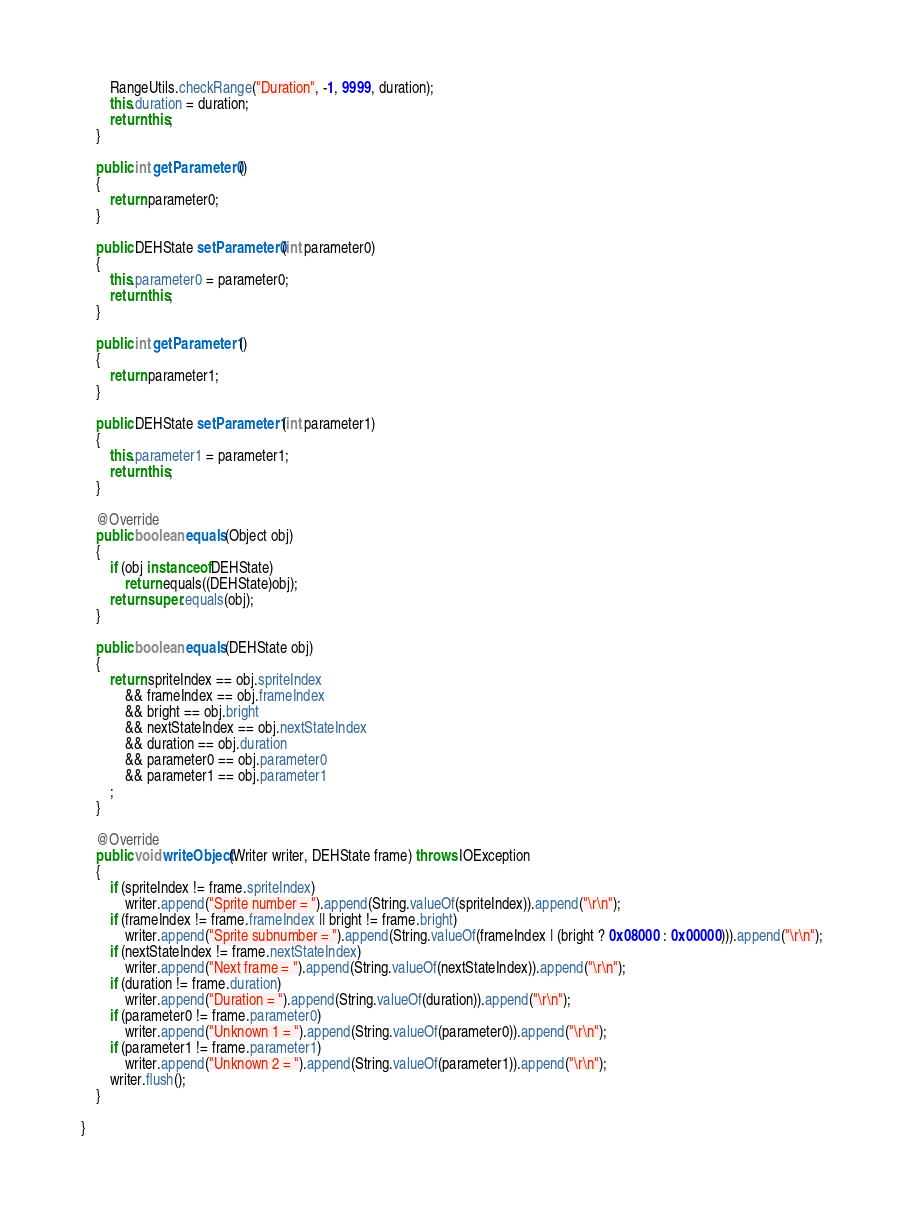Convert code to text. <code><loc_0><loc_0><loc_500><loc_500><_Java_>		RangeUtils.checkRange("Duration", -1, 9999, duration);
		this.duration = duration;
		return this;
	}
	
	public int getParameter0() 
	{
		return parameter0;
	}
	
	public DEHState setParameter0(int parameter0) 
	{
		this.parameter0 = parameter0;
		return this;
	}
	
	public int getParameter1()
	{
		return parameter1;
	}
	
	public DEHState setParameter1(int parameter1)
	{
		this.parameter1 = parameter1;
		return this;
	}
	
	@Override
	public boolean equals(Object obj) 
	{
		if (obj instanceof DEHState)
			return equals((DEHState)obj);
		return super.equals(obj);
	}
	
	public boolean equals(DEHState obj) 
	{
		return spriteIndex == obj.spriteIndex
			&& frameIndex == obj.frameIndex
			&& bright == obj.bright
			&& nextStateIndex == obj.nextStateIndex
			&& duration == obj.duration
			&& parameter0 == obj.parameter0
			&& parameter1 == obj.parameter1
		;
	}	
		
	@Override
	public void writeObject(Writer writer, DEHState frame) throws IOException
	{
		if (spriteIndex != frame.spriteIndex)
			writer.append("Sprite number = ").append(String.valueOf(spriteIndex)).append("\r\n");
		if (frameIndex != frame.frameIndex || bright != frame.bright)
			writer.append("Sprite subnumber = ").append(String.valueOf(frameIndex | (bright ? 0x08000 : 0x00000))).append("\r\n");
		if (nextStateIndex != frame.nextStateIndex)
			writer.append("Next frame = ").append(String.valueOf(nextStateIndex)).append("\r\n");
		if (duration != frame.duration)
			writer.append("Duration = ").append(String.valueOf(duration)).append("\r\n");
		if (parameter0 != frame.parameter0)
			writer.append("Unknown 1 = ").append(String.valueOf(parameter0)).append("\r\n");
		if (parameter1 != frame.parameter1)
			writer.append("Unknown 2 = ").append(String.valueOf(parameter1)).append("\r\n");
		writer.flush();
	}

}
</code> 